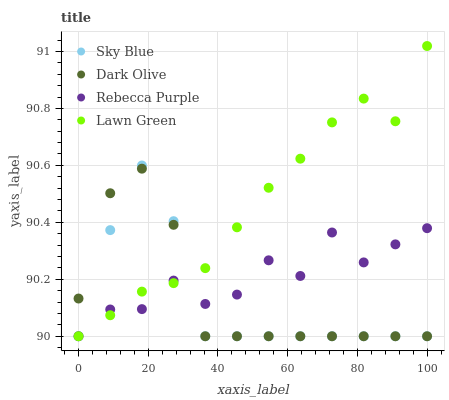Does Sky Blue have the minimum area under the curve?
Answer yes or no. Yes. Does Lawn Green have the maximum area under the curve?
Answer yes or no. Yes. Does Dark Olive have the minimum area under the curve?
Answer yes or no. No. Does Dark Olive have the maximum area under the curve?
Answer yes or no. No. Is Lawn Green the smoothest?
Answer yes or no. Yes. Is Rebecca Purple the roughest?
Answer yes or no. Yes. Is Dark Olive the smoothest?
Answer yes or no. No. Is Dark Olive the roughest?
Answer yes or no. No. Does Sky Blue have the lowest value?
Answer yes or no. Yes. Does Lawn Green have the highest value?
Answer yes or no. Yes. Does Dark Olive have the highest value?
Answer yes or no. No. Does Sky Blue intersect Rebecca Purple?
Answer yes or no. Yes. Is Sky Blue less than Rebecca Purple?
Answer yes or no. No. Is Sky Blue greater than Rebecca Purple?
Answer yes or no. No. 